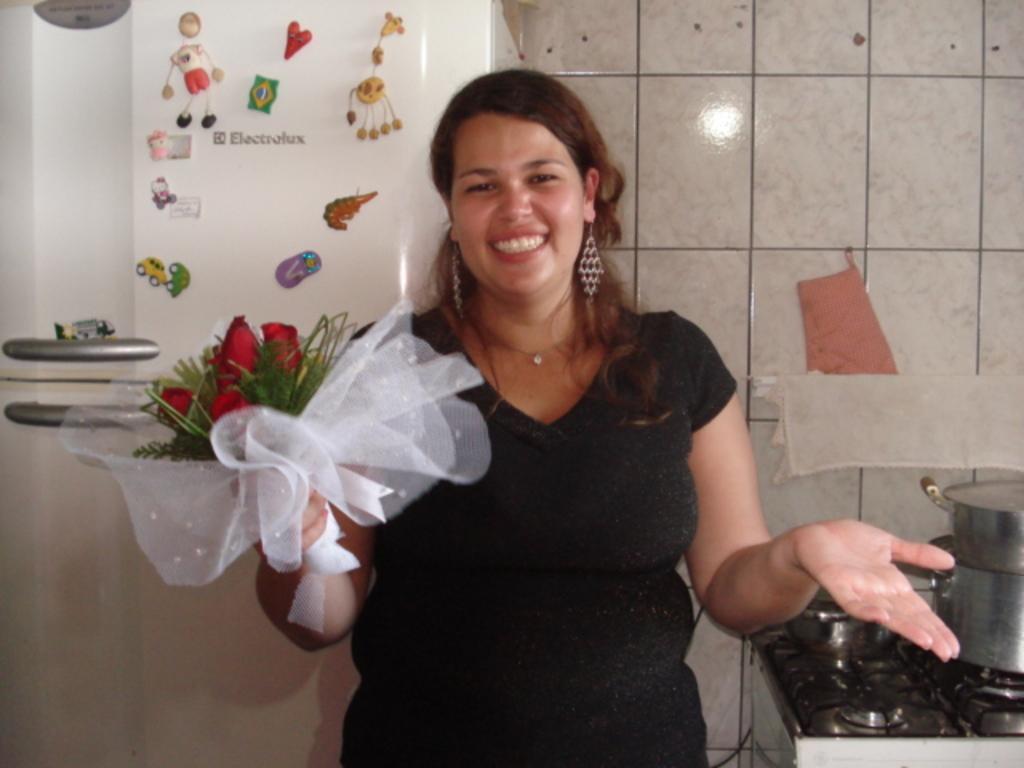Can you describe this image briefly? A women is holding bouquet, this is wall, here there is stove with utensils on it, this is refrigerator. 